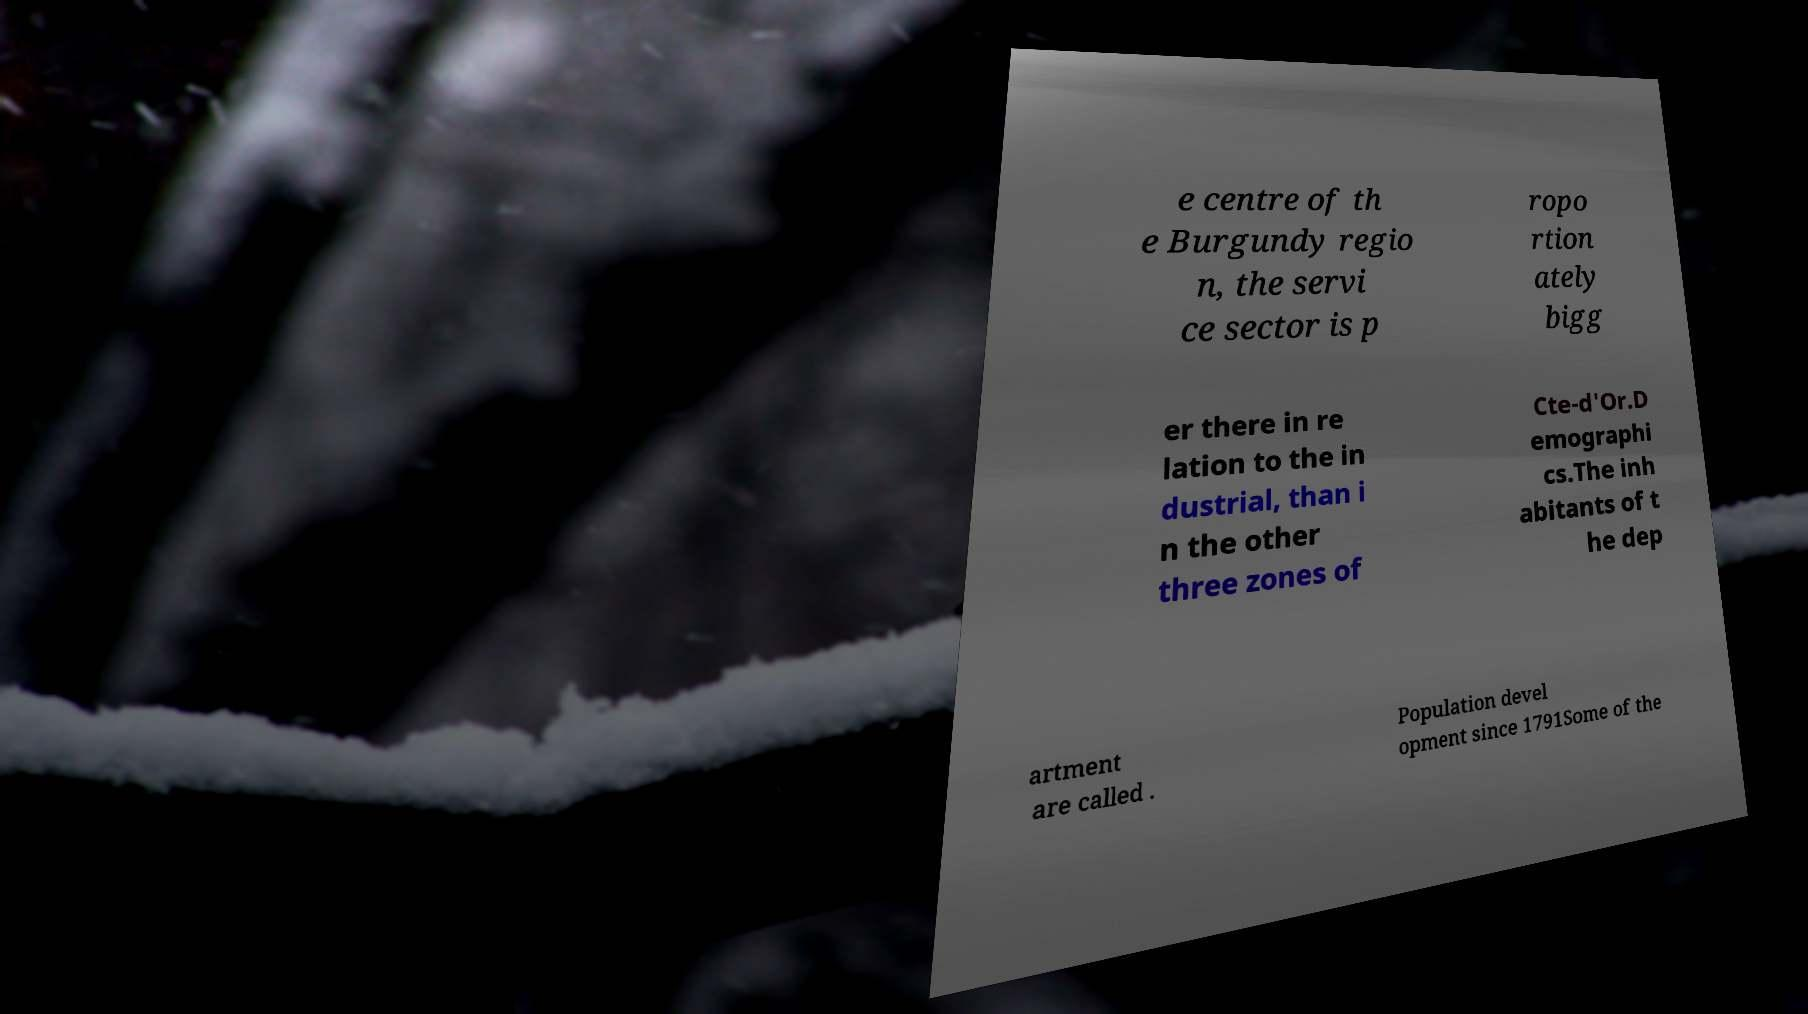There's text embedded in this image that I need extracted. Can you transcribe it verbatim? e centre of th e Burgundy regio n, the servi ce sector is p ropo rtion ately bigg er there in re lation to the in dustrial, than i n the other three zones of Cte-d'Or.D emographi cs.The inh abitants of t he dep artment are called . Population devel opment since 1791Some of the 